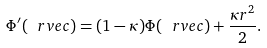<formula> <loc_0><loc_0><loc_500><loc_500>\Phi ^ { \prime } ( \ r v e c ) = ( 1 - \kappa ) \Phi ( \ r v e c ) + \frac { \kappa r ^ { 2 } } { 2 } .</formula> 